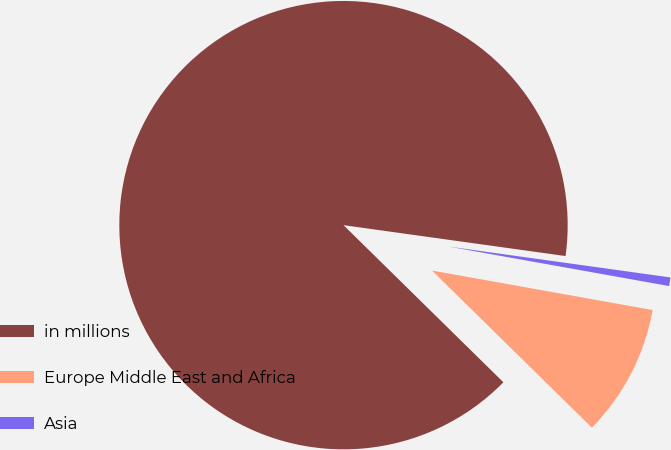Convert chart to OTSL. <chart><loc_0><loc_0><loc_500><loc_500><pie_chart><fcel>in millions<fcel>Europe Middle East and Africa<fcel>Asia<nl><fcel>89.83%<fcel>9.54%<fcel>0.62%<nl></chart> 